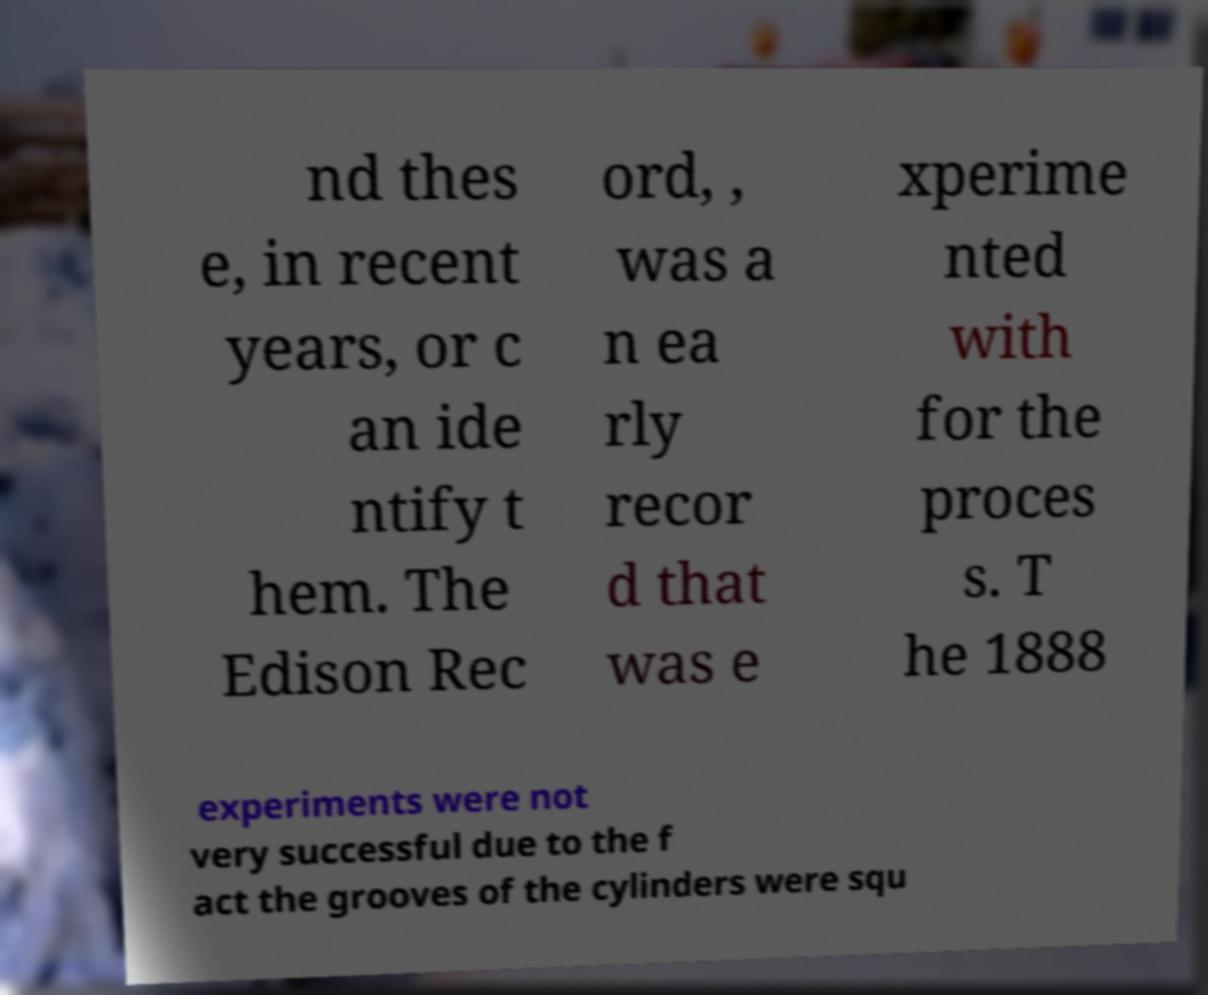Please read and relay the text visible in this image. What does it say? nd thes e, in recent years, or c an ide ntify t hem. The Edison Rec ord, , was a n ea rly recor d that was e xperime nted with for the proces s. T he 1888 experiments were not very successful due to the f act the grooves of the cylinders were squ 